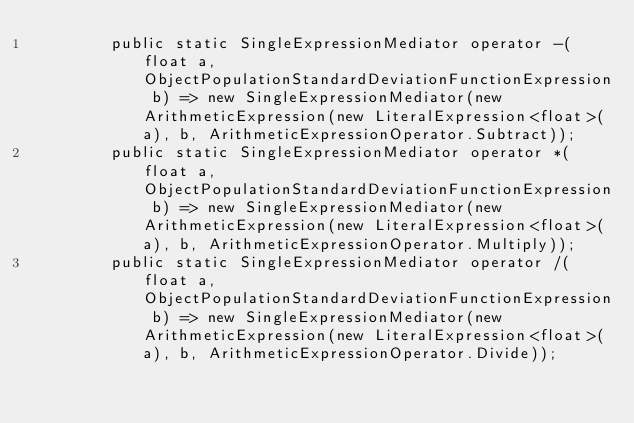<code> <loc_0><loc_0><loc_500><loc_500><_C#_>        public static SingleExpressionMediator operator -(float a, ObjectPopulationStandardDeviationFunctionExpression b) => new SingleExpressionMediator(new ArithmeticExpression(new LiteralExpression<float>(a), b, ArithmeticExpressionOperator.Subtract));
        public static SingleExpressionMediator operator *(float a, ObjectPopulationStandardDeviationFunctionExpression b) => new SingleExpressionMediator(new ArithmeticExpression(new LiteralExpression<float>(a), b, ArithmeticExpressionOperator.Multiply));
        public static SingleExpressionMediator operator /(float a, ObjectPopulationStandardDeviationFunctionExpression b) => new SingleExpressionMediator(new ArithmeticExpression(new LiteralExpression<float>(a), b, ArithmeticExpressionOperator.Divide));</code> 